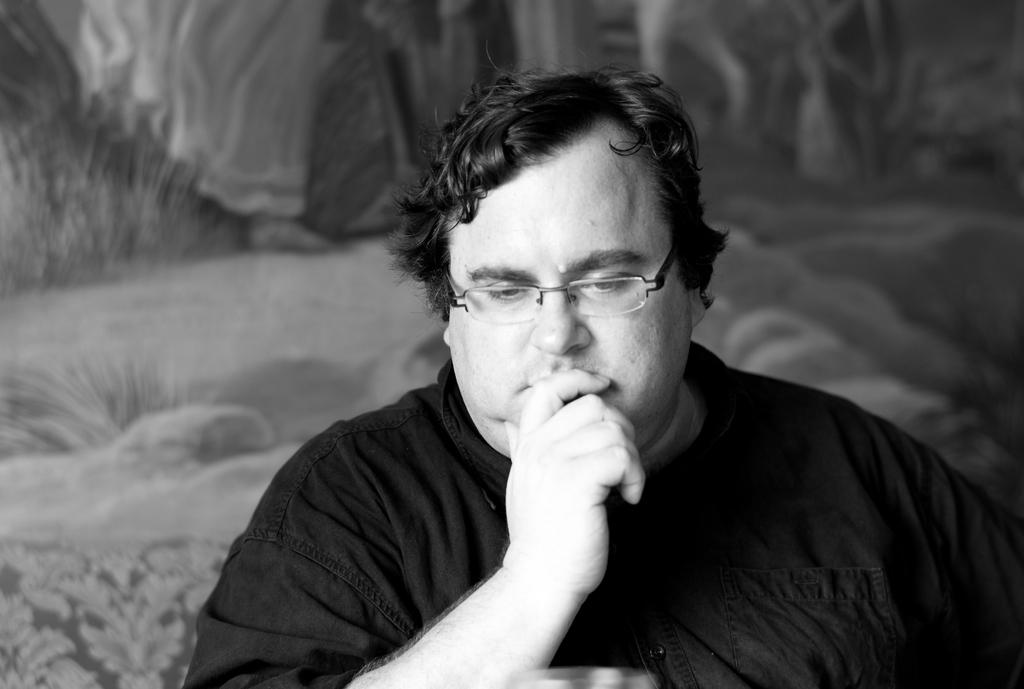What is happening in the image? There is a person in the image who is watching something. Can you describe the person's surroundings? There is a wall behind the person. What type of tail can be seen on the car in the image? There is no car present in the image, so there is no tail to be seen. 